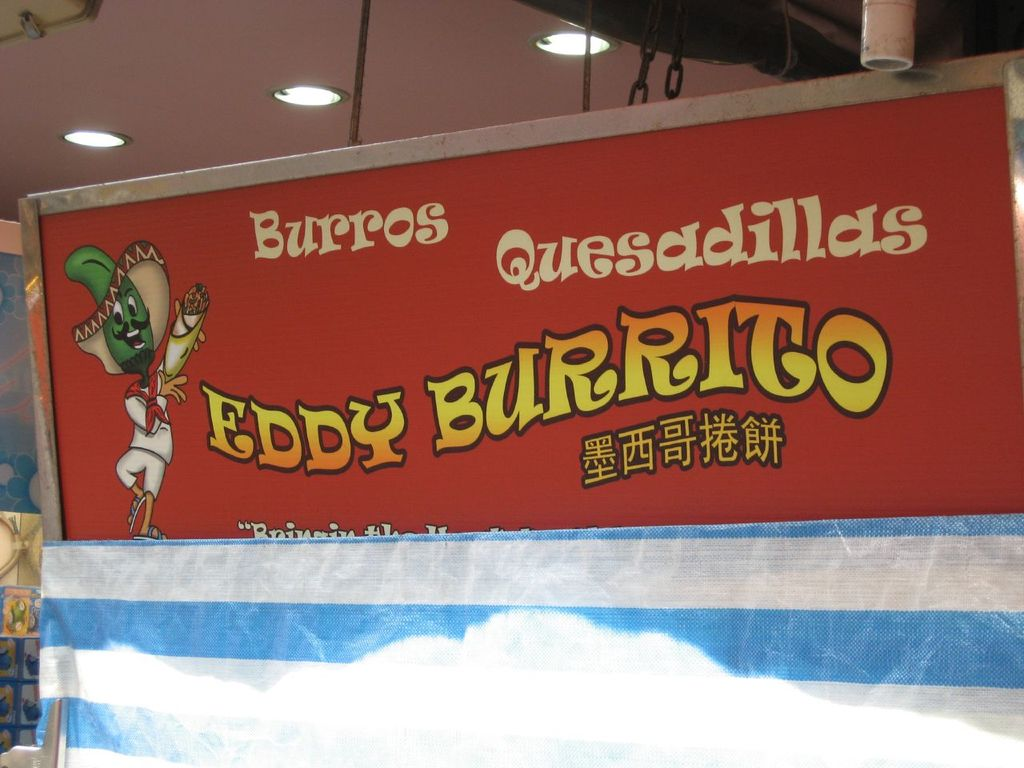Can you tell me more about the character design on the sign? Certainly! The character is designed to be both whimsical and culturally representative. It depicts a green lizard that stands upright, wearing a traditional Mexican sombrero, which is often seen in cultural representations to indicate a Mexican theme. The lizard's dynamic posture, with one hand raised holding a delicious looking burrito, adds an element of fun and invites viewers to try the food. This kind of playful and culturally themed mascot is effective in marketing, as it appeals to both children and adults while promoting the restaurant's specialty in a visually engaging way. 